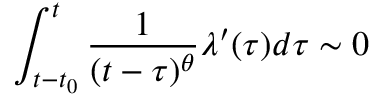<formula> <loc_0><loc_0><loc_500><loc_500>\int _ { t - t _ { 0 } } ^ { t } \frac { 1 } { ( t - \tau ) ^ { \theta } } \lambda ^ { \prime } ( \tau ) d \tau \sim 0</formula> 